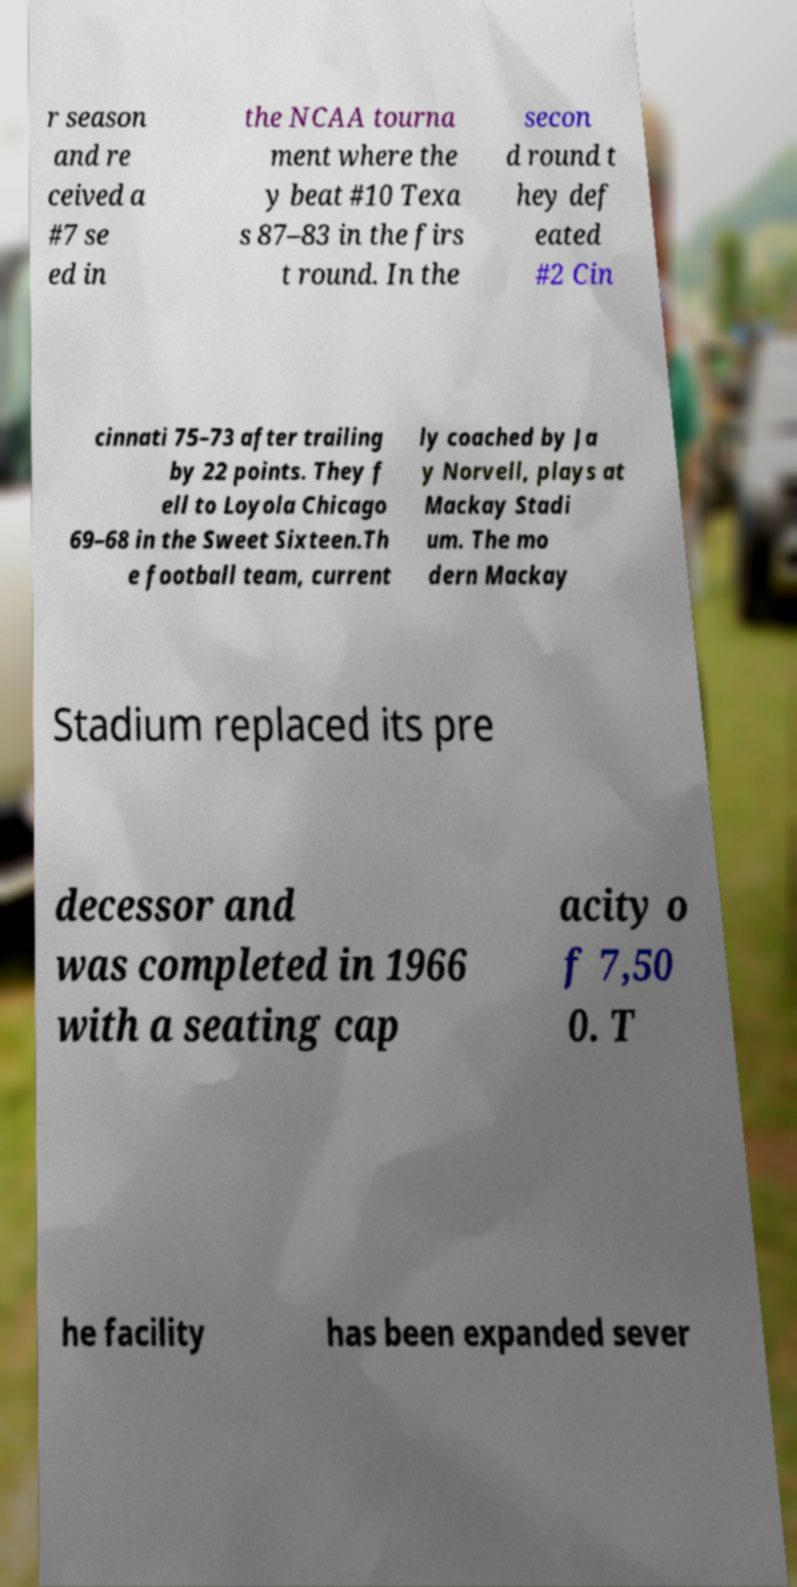There's text embedded in this image that I need extracted. Can you transcribe it verbatim? r season and re ceived a #7 se ed in the NCAA tourna ment where the y beat #10 Texa s 87–83 in the firs t round. In the secon d round t hey def eated #2 Cin cinnati 75–73 after trailing by 22 points. They f ell to Loyola Chicago 69–68 in the Sweet Sixteen.Th e football team, current ly coached by Ja y Norvell, plays at Mackay Stadi um. The mo dern Mackay Stadium replaced its pre decessor and was completed in 1966 with a seating cap acity o f 7,50 0. T he facility has been expanded sever 